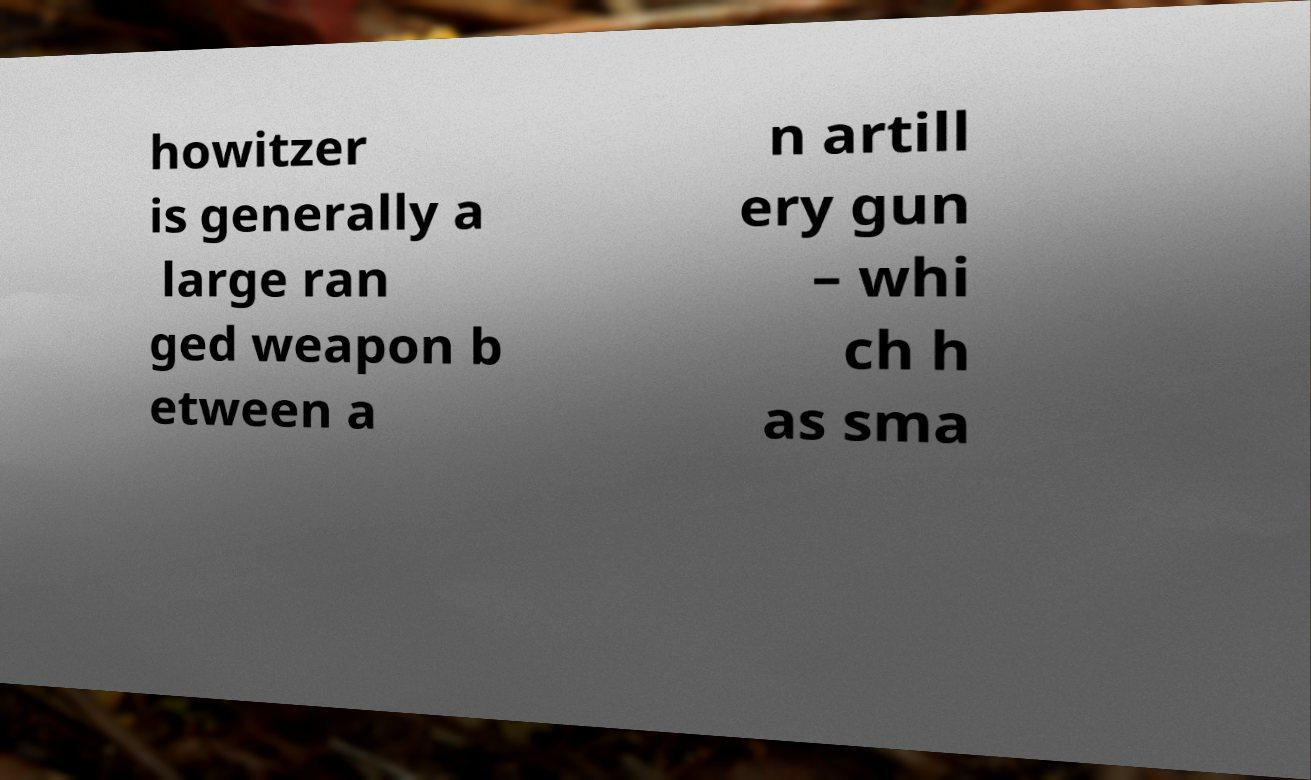Could you assist in decoding the text presented in this image and type it out clearly? howitzer is generally a large ran ged weapon b etween a n artill ery gun – whi ch h as sma 